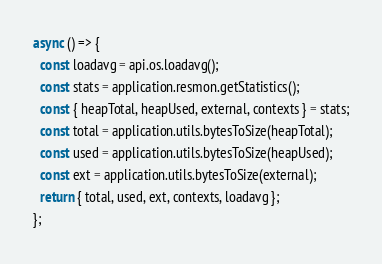Convert code to text. <code><loc_0><loc_0><loc_500><loc_500><_JavaScript_>async () => {
  const loadavg = api.os.loadavg();
  const stats = application.resmon.getStatistics();
  const { heapTotal, heapUsed, external, contexts } = stats;
  const total = application.utils.bytesToSize(heapTotal);
  const used = application.utils.bytesToSize(heapUsed);
  const ext = application.utils.bytesToSize(external);
  return { total, used, ext, contexts, loadavg };
};
</code> 